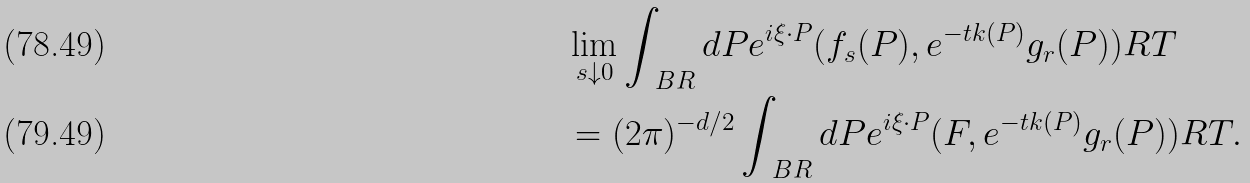<formula> <loc_0><loc_0><loc_500><loc_500>& \lim _ { s \downarrow 0 } \int _ { \ B R } d P e ^ { i \xi \cdot P } ( f _ { s } ( P ) , e ^ { - t k ( P ) } g _ { r } ( P ) ) _ { \L } R T \\ & = ( 2 \pi ) ^ { - d / 2 } \int _ { \ B R } d P e ^ { i \xi \cdot P } ( F , e ^ { - t k ( P ) } g _ { r } ( P ) ) _ { \L } R T .</formula> 